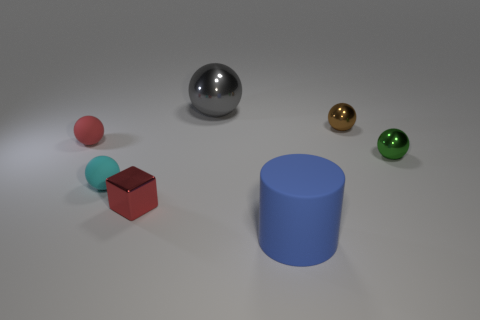Subtract all green spheres. How many spheres are left? 4 Subtract all tiny red spheres. How many spheres are left? 4 Subtract all blue balls. Subtract all brown cylinders. How many balls are left? 5 Add 2 large yellow blocks. How many objects exist? 9 Subtract all balls. How many objects are left? 2 Subtract all blue rubber cylinders. Subtract all blue things. How many objects are left? 5 Add 4 red cubes. How many red cubes are left? 5 Add 7 small red metal blocks. How many small red metal blocks exist? 8 Subtract 0 purple cylinders. How many objects are left? 7 